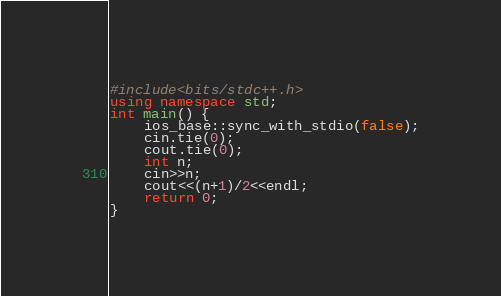<code> <loc_0><loc_0><loc_500><loc_500><_C++_>#include<bits/stdc++.h>
using namespace std;
int main() {
	ios_base::sync_with_stdio(false);
	cin.tie(0);
	cout.tie(0);
	int n;
	cin>>n;
	cout<<(n+1)/2<<endl;
	return 0;
}</code> 